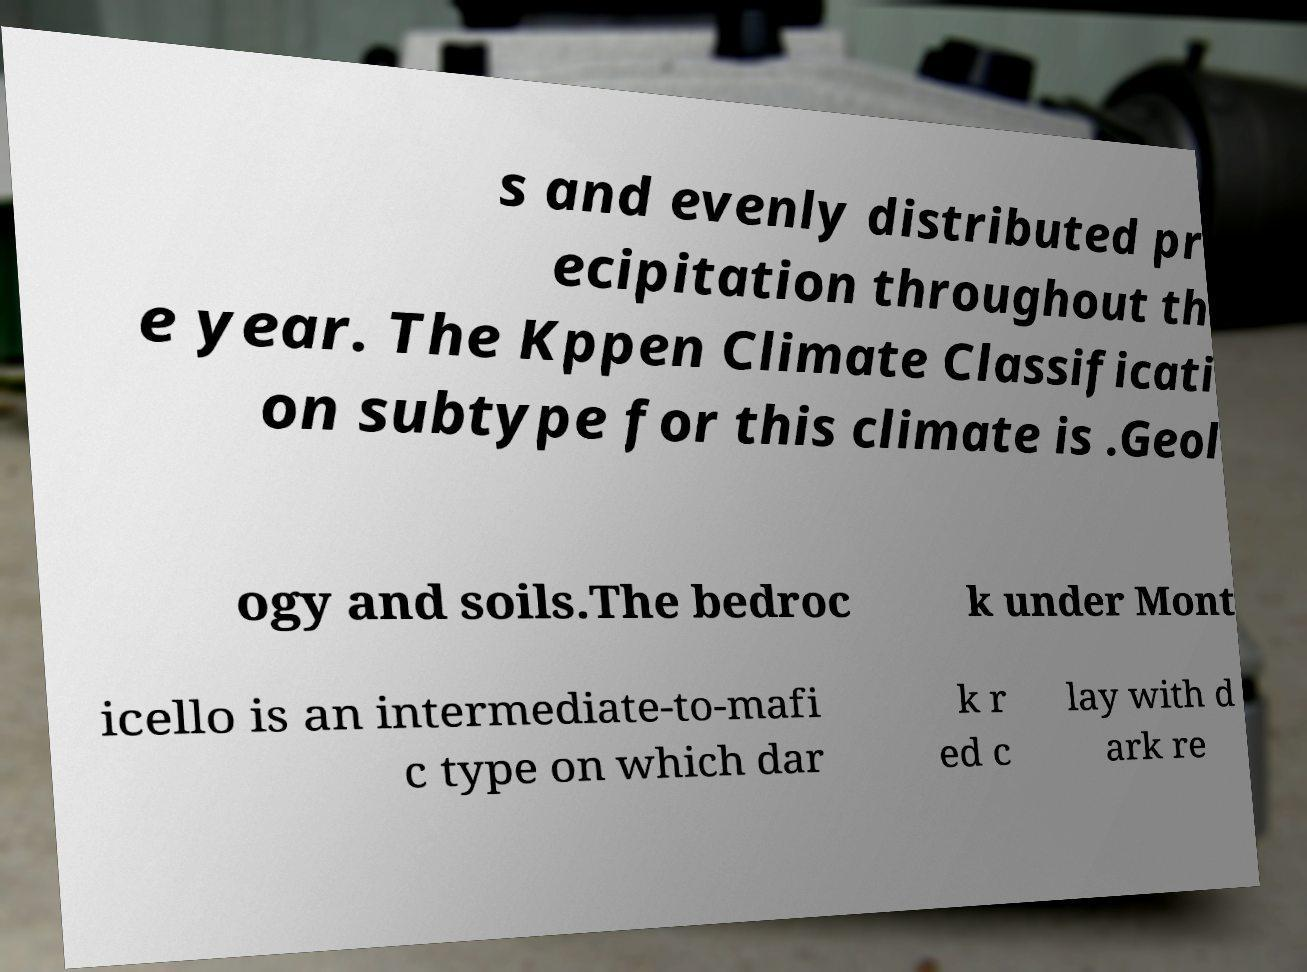There's text embedded in this image that I need extracted. Can you transcribe it verbatim? s and evenly distributed pr ecipitation throughout th e year. The Kppen Climate Classificati on subtype for this climate is .Geol ogy and soils.The bedroc k under Mont icello is an intermediate-to-mafi c type on which dar k r ed c lay with d ark re 